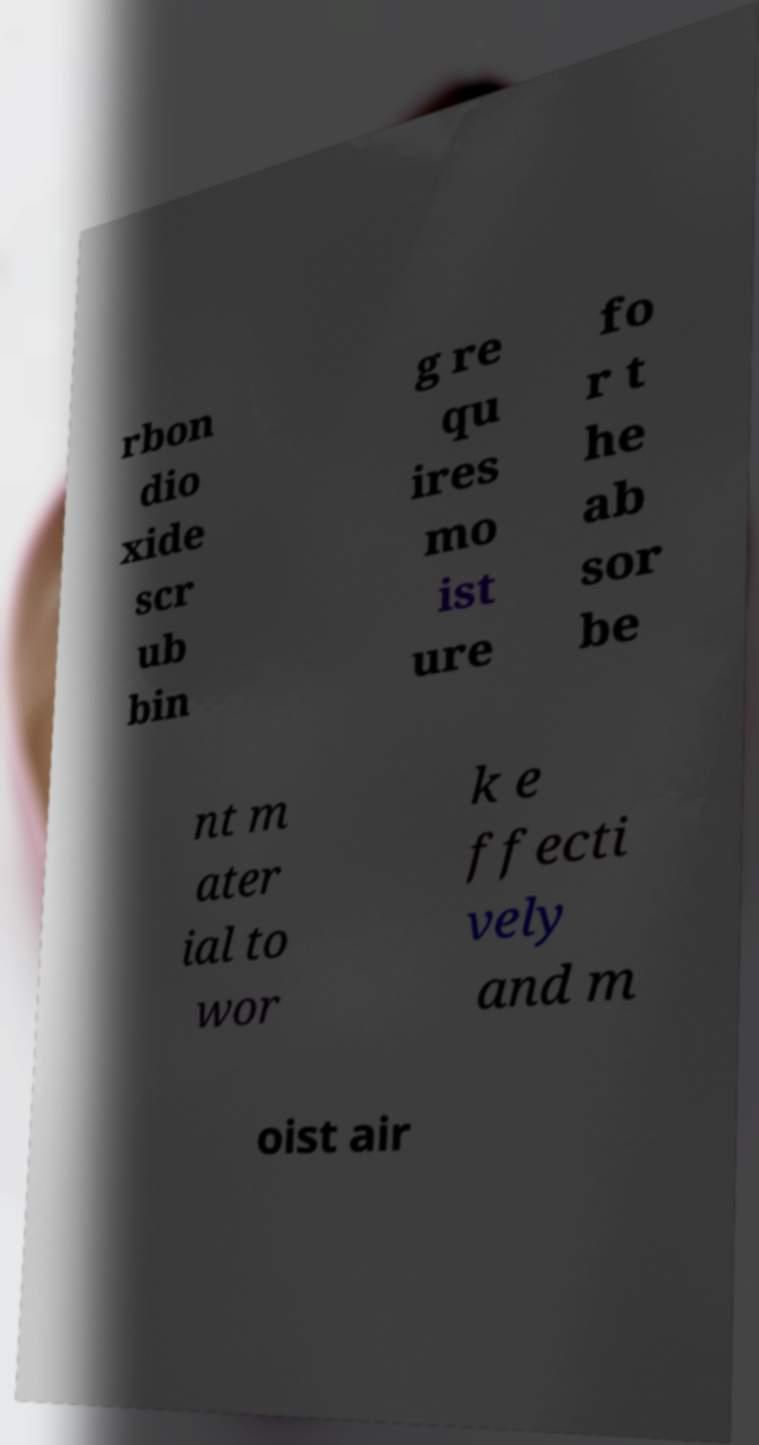Can you read and provide the text displayed in the image?This photo seems to have some interesting text. Can you extract and type it out for me? rbon dio xide scr ub bin g re qu ires mo ist ure fo r t he ab sor be nt m ater ial to wor k e ffecti vely and m oist air 